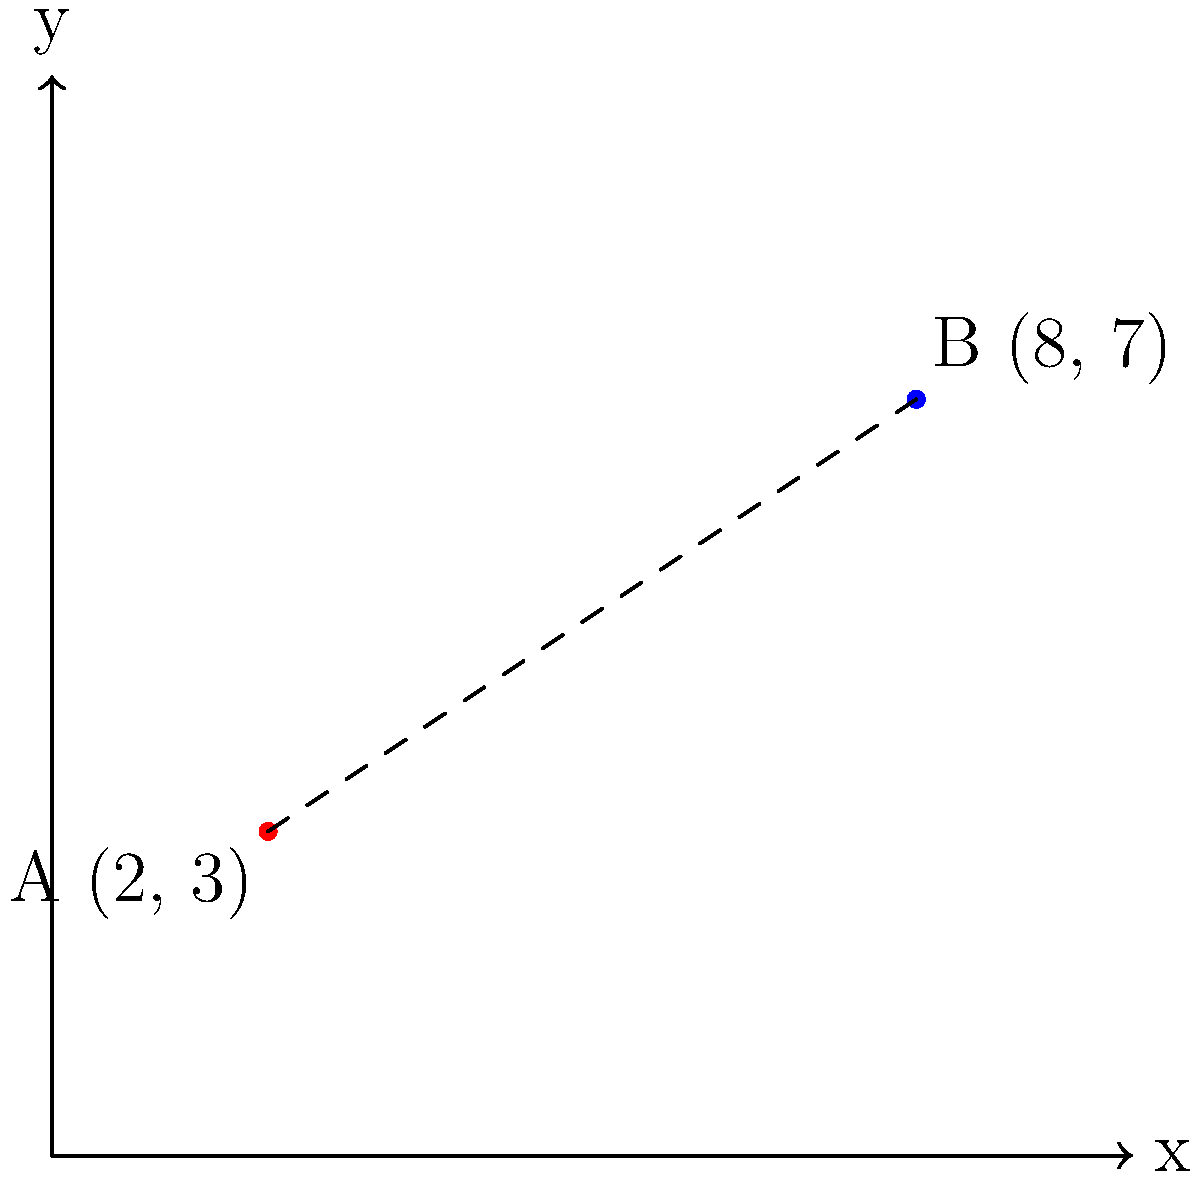As a social worker focusing on rural education, you're tasked with analyzing the distance between two schools to optimize resource allocation. On a map grid where each unit represents 1 km, School A is located at coordinates (2, 3) and School B is at (8, 7). Using the distance formula, calculate the straight-line distance between these two schools in kilometers. Round your answer to two decimal places. To solve this problem, we'll use the distance formula derived from the Pythagorean theorem:

$$ d = \sqrt{(x_2 - x_1)^2 + (y_2 - y_1)^2} $$

Where $(x_1, y_1)$ are the coordinates of the first point and $(x_2, y_2)$ are the coordinates of the second point.

Step 1: Identify the coordinates
- School A: $(x_1, y_1) = (2, 3)$
- School B: $(x_2, y_2) = (8, 7)$

Step 2: Plug the values into the distance formula
$$ d = \sqrt{(8 - 2)^2 + (7 - 3)^2} $$

Step 3: Simplify the expressions inside the parentheses
$$ d = \sqrt{6^2 + 4^2} $$

Step 4: Calculate the squares
$$ d = \sqrt{36 + 16} $$

Step 5: Add the values under the square root
$$ d = \sqrt{52} $$

Step 6: Calculate the square root and round to two decimal places
$$ d \approx 7.21 $$

Therefore, the straight-line distance between School A and School B is approximately 7.21 km.
Answer: 7.21 km 